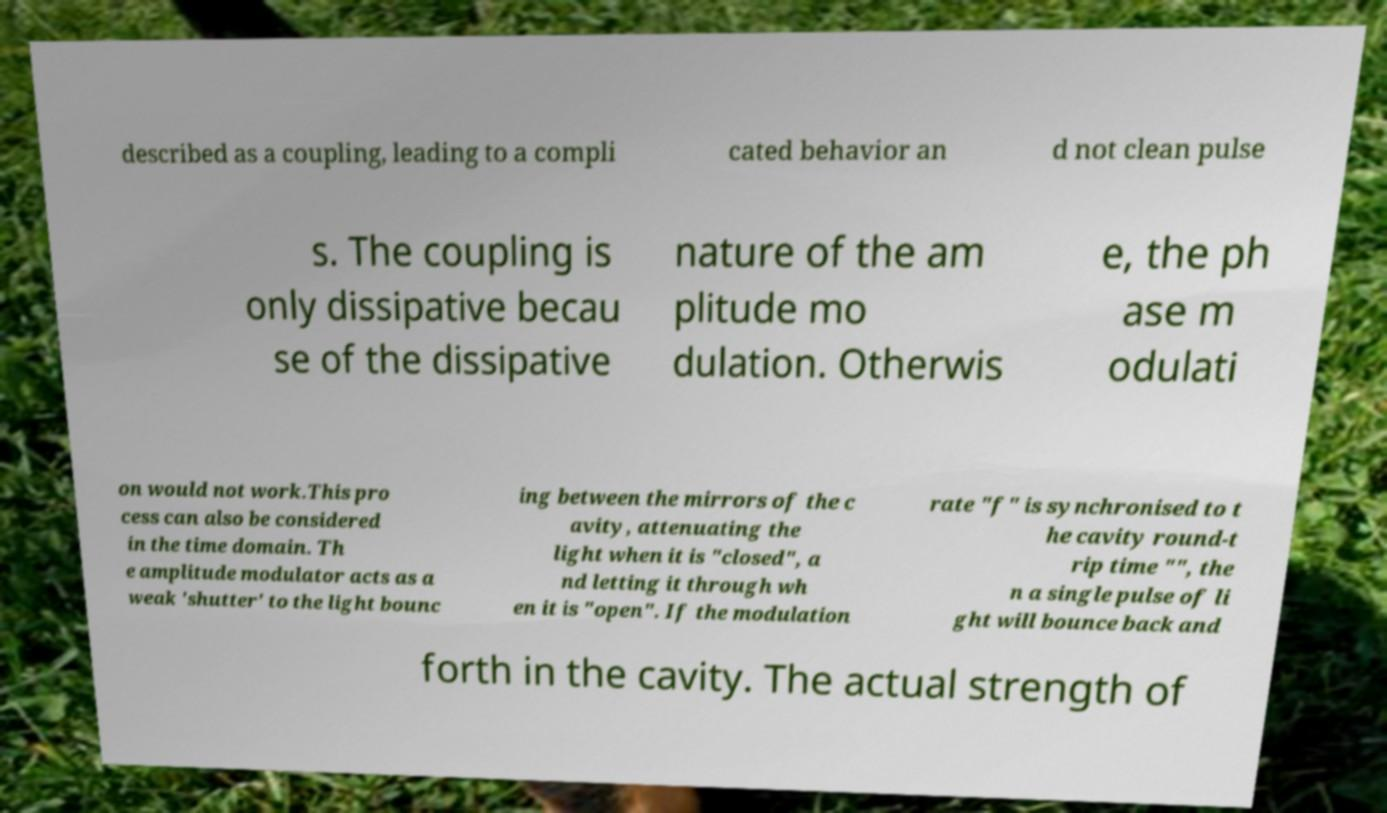I need the written content from this picture converted into text. Can you do that? described as a coupling, leading to a compli cated behavior an d not clean pulse s. The coupling is only dissipative becau se of the dissipative nature of the am plitude mo dulation. Otherwis e, the ph ase m odulati on would not work.This pro cess can also be considered in the time domain. Th e amplitude modulator acts as a weak 'shutter' to the light bounc ing between the mirrors of the c avity, attenuating the light when it is "closed", a nd letting it through wh en it is "open". If the modulation rate "f" is synchronised to t he cavity round-t rip time "", the n a single pulse of li ght will bounce back and forth in the cavity. The actual strength of 